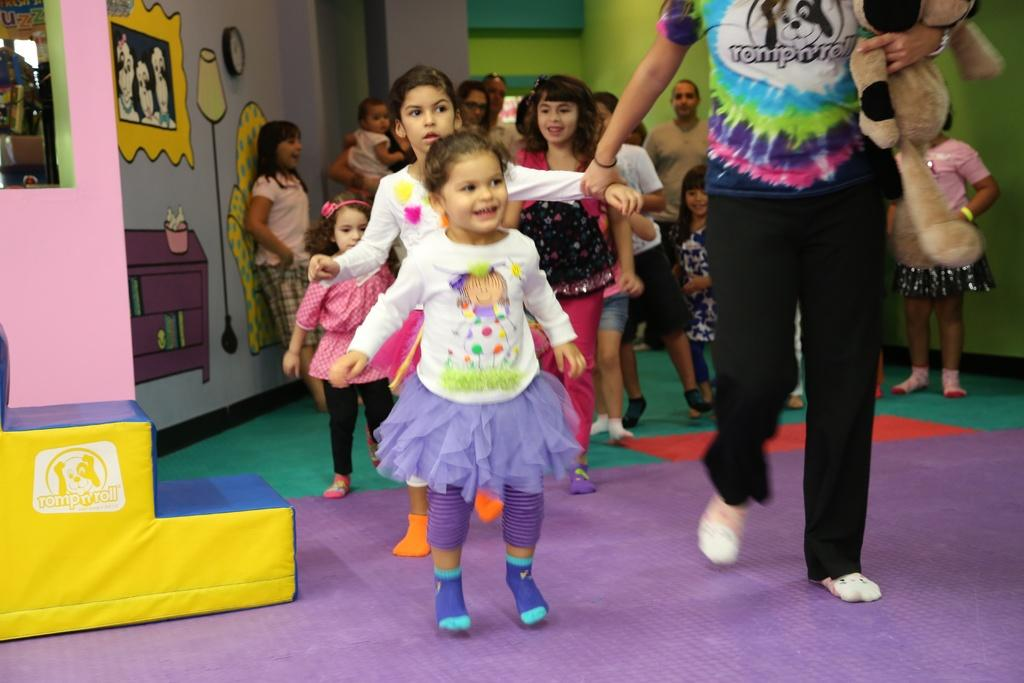How many people are in the image? There are persons in the image, but the exact number is not specified. What can be seen on the wall in the image? There are paintings on the wall in the image. What type of cheese is being served at the competition in the image? There is no mention of cheese, competition, or any food being served in the image. 